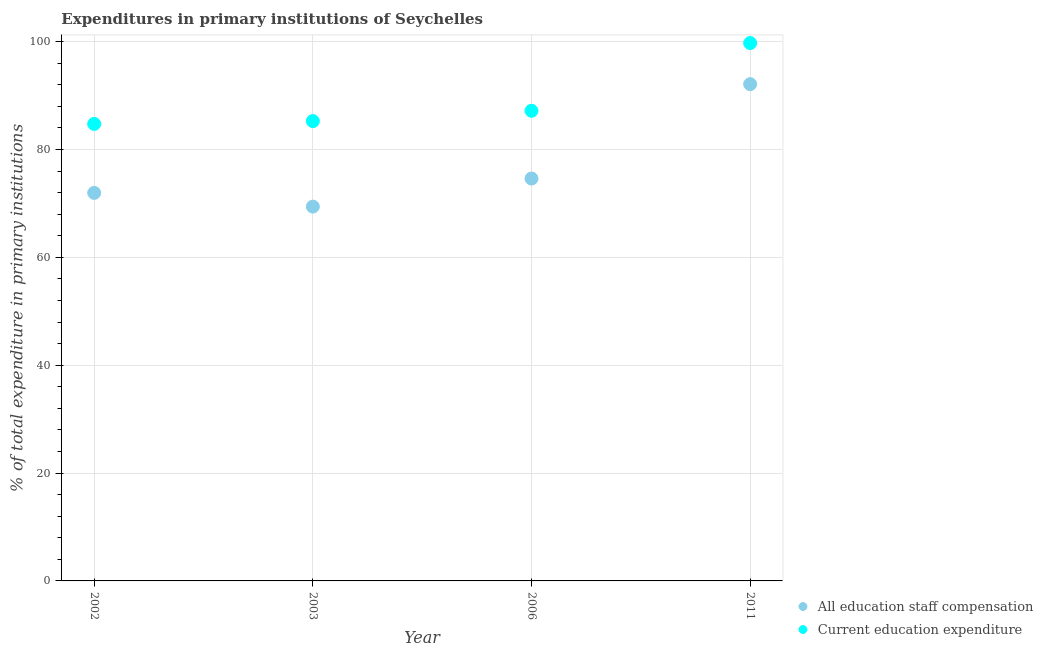What is the expenditure in education in 2011?
Ensure brevity in your answer.  99.74. Across all years, what is the maximum expenditure in staff compensation?
Provide a short and direct response. 92.12. Across all years, what is the minimum expenditure in staff compensation?
Keep it short and to the point. 69.41. In which year was the expenditure in education maximum?
Ensure brevity in your answer.  2011. What is the total expenditure in staff compensation in the graph?
Your answer should be very brief. 308.09. What is the difference between the expenditure in education in 2006 and that in 2011?
Ensure brevity in your answer.  -12.56. What is the difference between the expenditure in staff compensation in 2006 and the expenditure in education in 2002?
Make the answer very short. -10.13. What is the average expenditure in staff compensation per year?
Make the answer very short. 77.02. In the year 2003, what is the difference between the expenditure in staff compensation and expenditure in education?
Give a very brief answer. -15.86. What is the ratio of the expenditure in staff compensation in 2006 to that in 2011?
Make the answer very short. 0.81. What is the difference between the highest and the second highest expenditure in staff compensation?
Offer a terse response. 17.5. What is the difference between the highest and the lowest expenditure in education?
Keep it short and to the point. 14.99. In how many years, is the expenditure in staff compensation greater than the average expenditure in staff compensation taken over all years?
Offer a terse response. 1. Does the expenditure in staff compensation monotonically increase over the years?
Your answer should be very brief. No. Is the expenditure in staff compensation strictly greater than the expenditure in education over the years?
Your answer should be compact. No. How many years are there in the graph?
Offer a terse response. 4. What is the difference between two consecutive major ticks on the Y-axis?
Provide a short and direct response. 20. Are the values on the major ticks of Y-axis written in scientific E-notation?
Ensure brevity in your answer.  No. Does the graph contain any zero values?
Provide a succinct answer. No. How many legend labels are there?
Offer a terse response. 2. What is the title of the graph?
Your answer should be very brief. Expenditures in primary institutions of Seychelles. What is the label or title of the X-axis?
Give a very brief answer. Year. What is the label or title of the Y-axis?
Ensure brevity in your answer.  % of total expenditure in primary institutions. What is the % of total expenditure in primary institutions in All education staff compensation in 2002?
Offer a very short reply. 71.95. What is the % of total expenditure in primary institutions of Current education expenditure in 2002?
Provide a short and direct response. 84.74. What is the % of total expenditure in primary institutions of All education staff compensation in 2003?
Ensure brevity in your answer.  69.41. What is the % of total expenditure in primary institutions of Current education expenditure in 2003?
Provide a succinct answer. 85.27. What is the % of total expenditure in primary institutions in All education staff compensation in 2006?
Your response must be concise. 74.61. What is the % of total expenditure in primary institutions in Current education expenditure in 2006?
Offer a very short reply. 87.18. What is the % of total expenditure in primary institutions of All education staff compensation in 2011?
Give a very brief answer. 92.12. What is the % of total expenditure in primary institutions in Current education expenditure in 2011?
Offer a very short reply. 99.74. Across all years, what is the maximum % of total expenditure in primary institutions in All education staff compensation?
Give a very brief answer. 92.12. Across all years, what is the maximum % of total expenditure in primary institutions of Current education expenditure?
Provide a succinct answer. 99.74. Across all years, what is the minimum % of total expenditure in primary institutions of All education staff compensation?
Provide a succinct answer. 69.41. Across all years, what is the minimum % of total expenditure in primary institutions of Current education expenditure?
Your response must be concise. 84.74. What is the total % of total expenditure in primary institutions of All education staff compensation in the graph?
Provide a succinct answer. 308.09. What is the total % of total expenditure in primary institutions in Current education expenditure in the graph?
Keep it short and to the point. 356.92. What is the difference between the % of total expenditure in primary institutions in All education staff compensation in 2002 and that in 2003?
Keep it short and to the point. 2.54. What is the difference between the % of total expenditure in primary institutions of Current education expenditure in 2002 and that in 2003?
Your answer should be compact. -0.53. What is the difference between the % of total expenditure in primary institutions of All education staff compensation in 2002 and that in 2006?
Offer a terse response. -2.66. What is the difference between the % of total expenditure in primary institutions of Current education expenditure in 2002 and that in 2006?
Provide a succinct answer. -2.44. What is the difference between the % of total expenditure in primary institutions of All education staff compensation in 2002 and that in 2011?
Your response must be concise. -20.16. What is the difference between the % of total expenditure in primary institutions of Current education expenditure in 2002 and that in 2011?
Ensure brevity in your answer.  -14.99. What is the difference between the % of total expenditure in primary institutions of All education staff compensation in 2003 and that in 2006?
Make the answer very short. -5.2. What is the difference between the % of total expenditure in primary institutions of Current education expenditure in 2003 and that in 2006?
Offer a terse response. -1.91. What is the difference between the % of total expenditure in primary institutions in All education staff compensation in 2003 and that in 2011?
Ensure brevity in your answer.  -22.71. What is the difference between the % of total expenditure in primary institutions of Current education expenditure in 2003 and that in 2011?
Offer a terse response. -14.47. What is the difference between the % of total expenditure in primary institutions of All education staff compensation in 2006 and that in 2011?
Your response must be concise. -17.5. What is the difference between the % of total expenditure in primary institutions of Current education expenditure in 2006 and that in 2011?
Your answer should be compact. -12.56. What is the difference between the % of total expenditure in primary institutions of All education staff compensation in 2002 and the % of total expenditure in primary institutions of Current education expenditure in 2003?
Give a very brief answer. -13.31. What is the difference between the % of total expenditure in primary institutions in All education staff compensation in 2002 and the % of total expenditure in primary institutions in Current education expenditure in 2006?
Keep it short and to the point. -15.22. What is the difference between the % of total expenditure in primary institutions of All education staff compensation in 2002 and the % of total expenditure in primary institutions of Current education expenditure in 2011?
Your response must be concise. -27.78. What is the difference between the % of total expenditure in primary institutions of All education staff compensation in 2003 and the % of total expenditure in primary institutions of Current education expenditure in 2006?
Offer a very short reply. -17.77. What is the difference between the % of total expenditure in primary institutions in All education staff compensation in 2003 and the % of total expenditure in primary institutions in Current education expenditure in 2011?
Make the answer very short. -30.33. What is the difference between the % of total expenditure in primary institutions of All education staff compensation in 2006 and the % of total expenditure in primary institutions of Current education expenditure in 2011?
Make the answer very short. -25.13. What is the average % of total expenditure in primary institutions of All education staff compensation per year?
Make the answer very short. 77.02. What is the average % of total expenditure in primary institutions in Current education expenditure per year?
Offer a very short reply. 89.23. In the year 2002, what is the difference between the % of total expenditure in primary institutions in All education staff compensation and % of total expenditure in primary institutions in Current education expenditure?
Your answer should be compact. -12.79. In the year 2003, what is the difference between the % of total expenditure in primary institutions in All education staff compensation and % of total expenditure in primary institutions in Current education expenditure?
Keep it short and to the point. -15.86. In the year 2006, what is the difference between the % of total expenditure in primary institutions of All education staff compensation and % of total expenditure in primary institutions of Current education expenditure?
Keep it short and to the point. -12.57. In the year 2011, what is the difference between the % of total expenditure in primary institutions of All education staff compensation and % of total expenditure in primary institutions of Current education expenditure?
Offer a very short reply. -7.62. What is the ratio of the % of total expenditure in primary institutions of All education staff compensation in 2002 to that in 2003?
Offer a very short reply. 1.04. What is the ratio of the % of total expenditure in primary institutions of All education staff compensation in 2002 to that in 2006?
Ensure brevity in your answer.  0.96. What is the ratio of the % of total expenditure in primary institutions in Current education expenditure in 2002 to that in 2006?
Offer a terse response. 0.97. What is the ratio of the % of total expenditure in primary institutions in All education staff compensation in 2002 to that in 2011?
Provide a succinct answer. 0.78. What is the ratio of the % of total expenditure in primary institutions in Current education expenditure in 2002 to that in 2011?
Your response must be concise. 0.85. What is the ratio of the % of total expenditure in primary institutions in All education staff compensation in 2003 to that in 2006?
Keep it short and to the point. 0.93. What is the ratio of the % of total expenditure in primary institutions of Current education expenditure in 2003 to that in 2006?
Provide a succinct answer. 0.98. What is the ratio of the % of total expenditure in primary institutions in All education staff compensation in 2003 to that in 2011?
Ensure brevity in your answer.  0.75. What is the ratio of the % of total expenditure in primary institutions in Current education expenditure in 2003 to that in 2011?
Your answer should be very brief. 0.85. What is the ratio of the % of total expenditure in primary institutions in All education staff compensation in 2006 to that in 2011?
Give a very brief answer. 0.81. What is the ratio of the % of total expenditure in primary institutions of Current education expenditure in 2006 to that in 2011?
Ensure brevity in your answer.  0.87. What is the difference between the highest and the second highest % of total expenditure in primary institutions of All education staff compensation?
Give a very brief answer. 17.5. What is the difference between the highest and the second highest % of total expenditure in primary institutions in Current education expenditure?
Keep it short and to the point. 12.56. What is the difference between the highest and the lowest % of total expenditure in primary institutions of All education staff compensation?
Your response must be concise. 22.71. What is the difference between the highest and the lowest % of total expenditure in primary institutions in Current education expenditure?
Your answer should be compact. 14.99. 